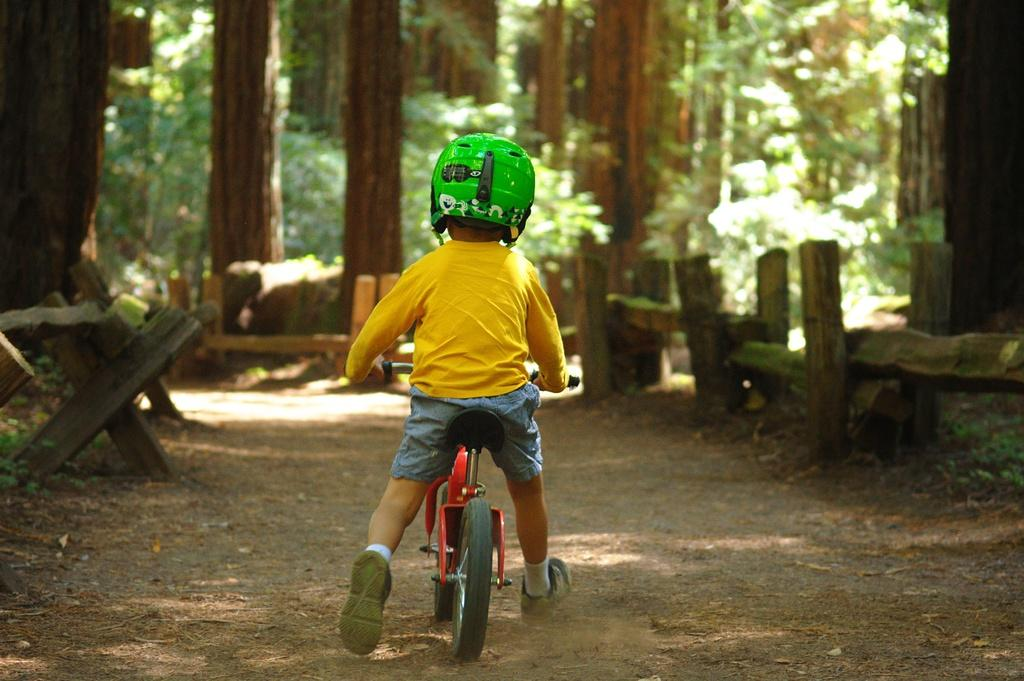Who is the main subject in the image? There is a boy in the image. What is the boy wearing? The boy is wearing a t-shirt and shorts. What is the boy doing in the image? The boy is sitting on a bicycle. What safety gear is the boy wearing? The boy is wearing a green color helmet. What can be seen in the background of the image? There are trees in the background of the image. What type of soap can be seen in the image? There is no soap present in the image. What scent is associated with the boy in the image? There is no mention of a scent associated with the boy in the image. 